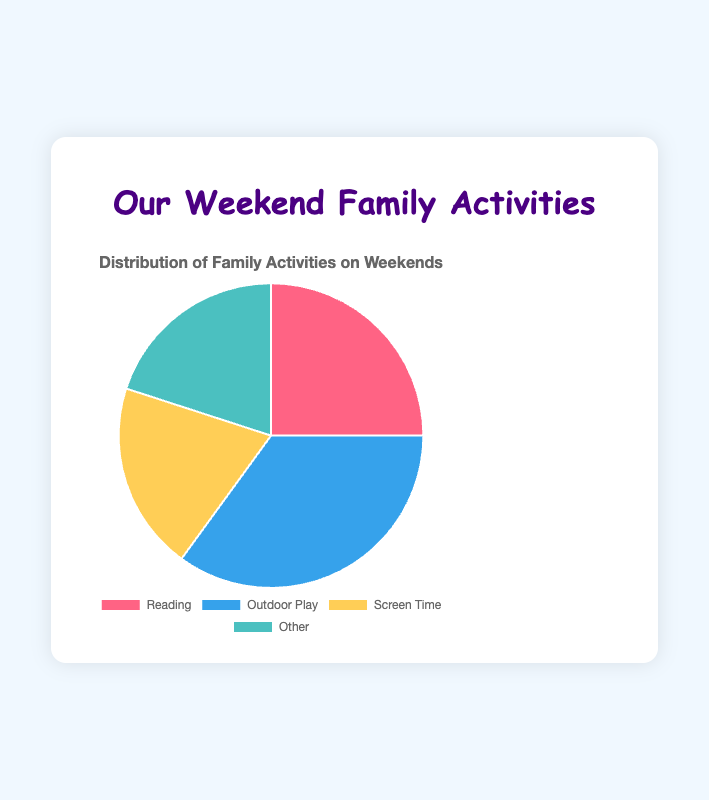Which activity has the highest percentage? The figure shows that Outdoor Play has the largest portion in the pie chart.
Answer: Outdoor Play What is the combined percentage of Reading and Screen Time? Sum the percentages of Reading (25%) and Screen Time (20%): 25 + 20 = 45.
Answer: 45 Which two activities have equal percentages? The figure shows that both Screen Time and Other have the same percentage, 20%.
Answer: Screen Time and Other How much greater is the percentage of Outdoor Play compared to Reading? Subtract the percentage of Reading (25%) from the percentage of Outdoor Play (35%): 35 - 25 = 10.
Answer: 10 What is the difference in percentage between Outdoor Play and the combined percentage of Screen Time and Other? First, sum the percentages of Screen Time (20%) and Other (20%): 20 + 20 = 40. Then, subtract the percentage of Outdoor Play (35%): 40 - 35 = 5.
Answer: 5 Which activity has the smallest portion in the pie chart? The figure shows that Screen Time and Other have the smallest portions, both with 20%.
Answer: Screen Time and Other If we combine Screen Time and Other, what will be their total percentage compared to Outdoor Play? Sum the percentages of Screen Time (20%) and Other (20%): 20 + 20 = 40. Compare it to Outdoor Play (35%): 40 is greater than 35.
Answer: 40 is greater than 35 What is the average percentage of the activities? Sum the percentages of all activities and divide by the number of activities: (25 + 35 + 20 + 20) / 4 = 100 / 4 = 25.
Answer: 25 Which activity is represented by the blue section of the pie chart? The pie chart shows that Outdoor Play is represented by the blue section.
Answer: Outdoor Play What is the total percentage of activities that are not spent on outdoor play? Subtract the percentage of Outdoor Play (35%) from 100%: 100 - 35 = 65.
Answer: 65 